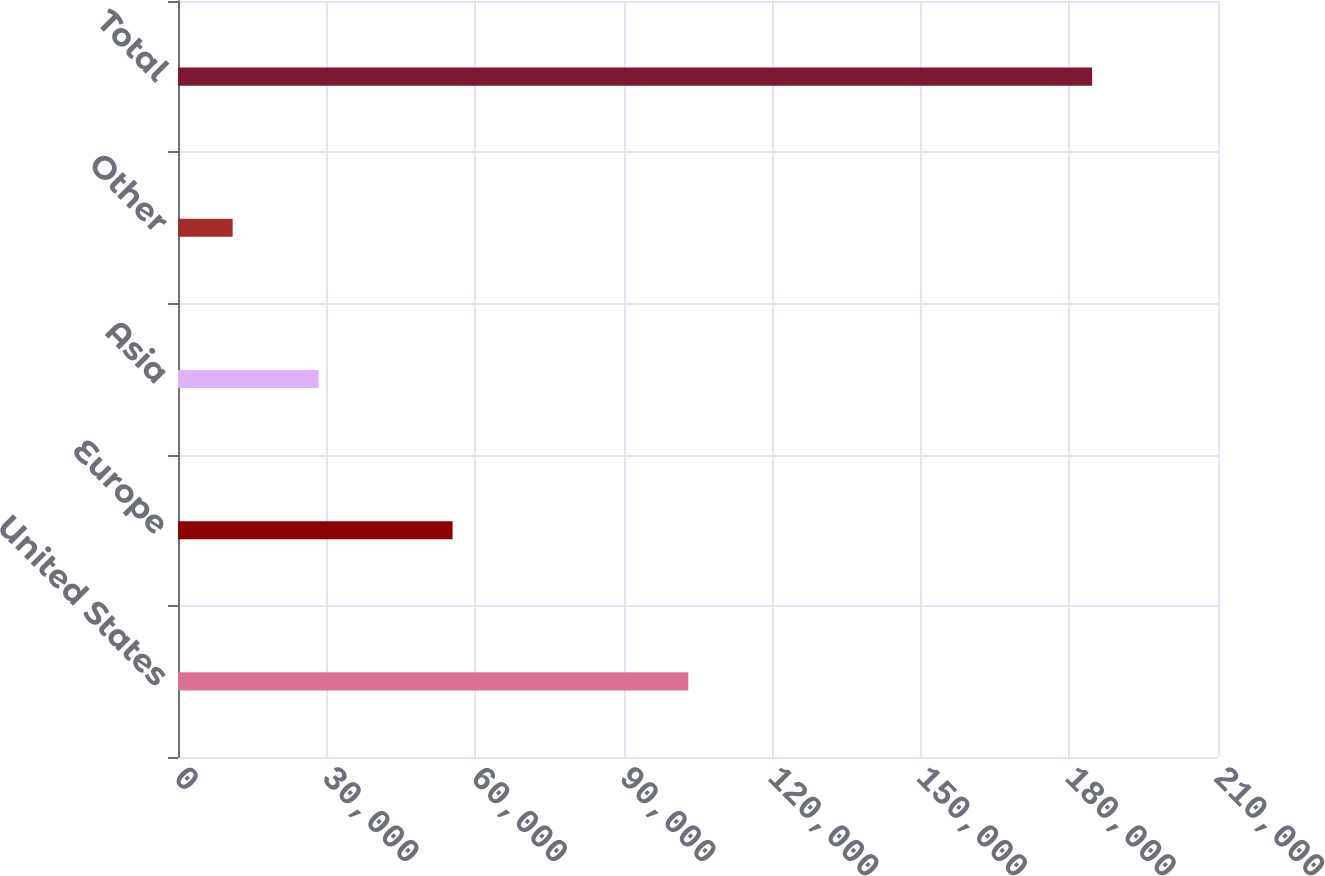Convert chart to OTSL. <chart><loc_0><loc_0><loc_500><loc_500><bar_chart><fcel>United States<fcel>Europe<fcel>Asia<fcel>Other<fcel>Total<nl><fcel>103043<fcel>55440<fcel>28388.3<fcel>11033<fcel>184586<nl></chart> 